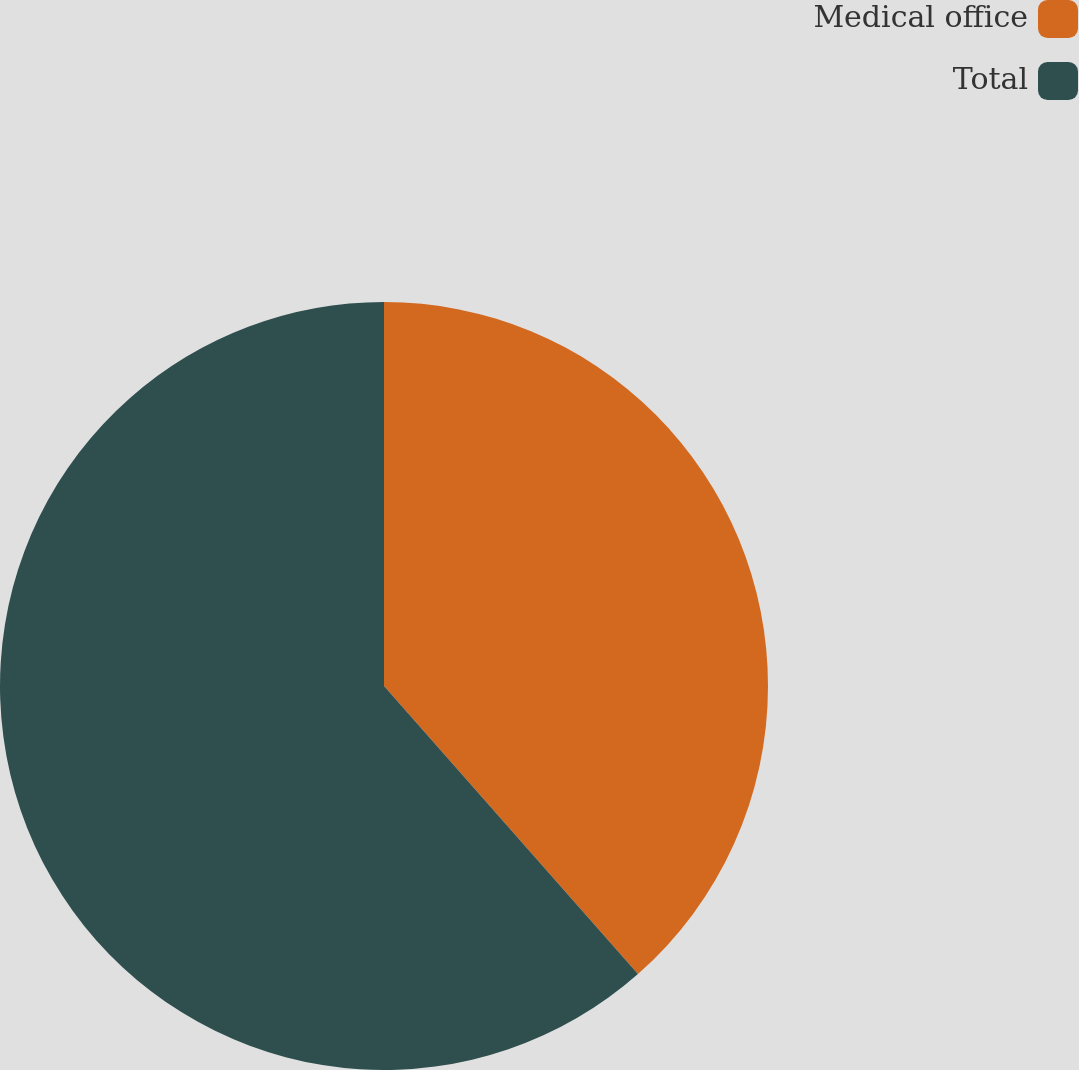Convert chart to OTSL. <chart><loc_0><loc_0><loc_500><loc_500><pie_chart><fcel>Medical office<fcel>Total<nl><fcel>38.5%<fcel>61.5%<nl></chart> 